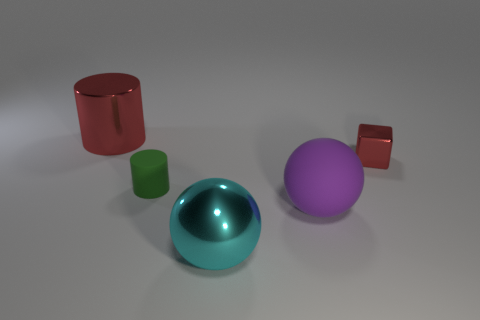There is a red object that is right of the big red shiny thing; does it have the same shape as the cyan metallic object?
Ensure brevity in your answer.  No. The cylinder that is in front of the big red thing is what color?
Keep it short and to the point. Green. What shape is the other large thing that is the same material as the large cyan object?
Keep it short and to the point. Cylinder. Are there any other things of the same color as the large metal cylinder?
Ensure brevity in your answer.  Yes. Is the number of large cyan things that are left of the small green thing greater than the number of big purple rubber objects that are behind the small metal cube?
Provide a short and direct response. No. How many rubber spheres have the same size as the block?
Provide a short and direct response. 0. Are there fewer small cubes to the right of the small red block than tiny green matte objects that are on the right side of the big red cylinder?
Give a very brief answer. Yes. Are there any blue matte things that have the same shape as the large cyan thing?
Ensure brevity in your answer.  No. Is the shape of the small red object the same as the big red object?
Give a very brief answer. No. What number of big things are either cylinders or cyan shiny balls?
Offer a very short reply. 2. 